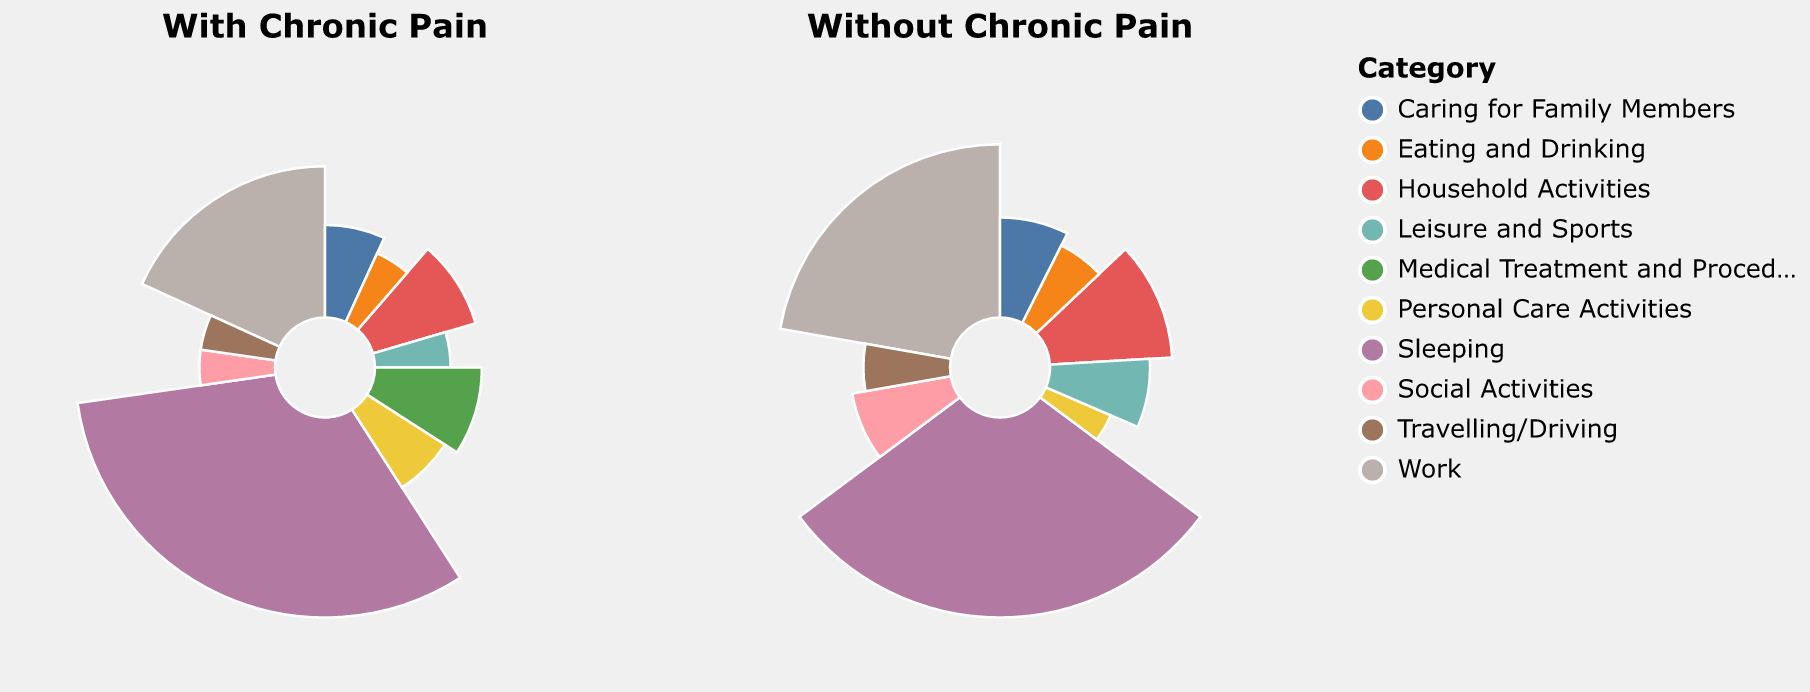Which category shows the largest difference in time spent between those with chronic pain and without? To determine the largest difference, compare the time values for each category in both subplots. The "Work" category shows a difference of 2 hours (6 without chronic pain vs. 4 with chronic pain).
Answer: Work Which categories have participants spending the same amount of time regardless of chronic pain? Check for categories where the hours are the same in both subplots. The "Eating and Drinking" category shows participants spending 1 hour regardless of chronic pain.
Answer: Eating and Drinking How much less time do individuals with chronic pain spend on social activities compared to those without? In the "Social Activities" category, those with chronic pain spend 1 hour, while those without spend 2 hours. The difference is 1 hour.
Answer: 1 hour Summarize the total time spent on Medical Treatment and Procedures in both conditions. Add the time spent on "Medical Treatment and Procedures" for both conditions: 2 hours for those with chronic pain and 0 hours for those without. The total time spent is 2 hours.
Answer: 2 hours Which category has the least change in time spent when comparing between chronic pain and no chronic pain? Find the category with the smallest numerical difference in time spent. The "Travelling/Driving" category has a difference of 0.5 hours (1.5 - 1.0).
Answer: Travelling/Driving For which categories do individuals with chronic pain spend more time compared to individuals without chronic pain? Identify categories where time spent is higher for individuals with chronic pain. "Personal Care Activities" (1.5 vs 1.0) and "Medical Treatment and Procedures" (2.0 vs 0.0) fall into this category.
Answer: Personal Care Activities, Medical Treatment and Procedures Compare the total time spent on Leisure and Sports for both groups and identify the difference. Sum the time spent on "Leisure and Sports": 1 hour for chronic pain and 2 hours without chronic pain. The difference is 1 hour.
Answer: 1 hour How does the proportion of time spent on household activities differ between those with chronic pain and those without? The proportion is calculated relative to the total hours considered (24 hours). For chronic pain: 2/24 = 8.3%. Without chronic pain: 3/24 = 12.5%.
Answer: The proportion is 4.2% less for those with chronic pain What is the total time spent on caring for family members in both groups combined? Add the time spent in "Caring for Family Members" for both groups: 1.5 hours for chronic pain and 2 hours without chronic pain. The total is 3.5 hours.
Answer: 3.5 hours Which category has the highest time spent in the absence of chronic pain? Identify the category with the highest numeric value in the "Without Chronic Pain" subplot. "Sleeping" has 8 hours, which is the highest.
Answer: Sleeping 